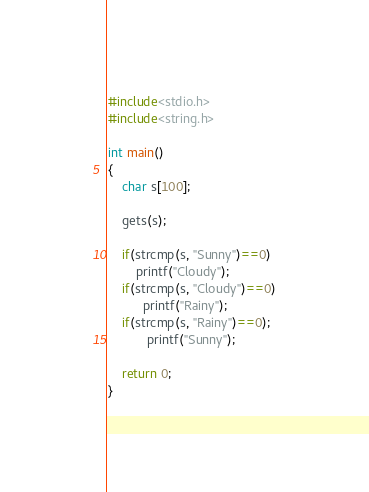Convert code to text. <code><loc_0><loc_0><loc_500><loc_500><_C_>#include<stdio.h>
#include<string.h>
 
int main()
{
    char s[100];
 
    gets(s);
 
    if(strcmp(s, "Sunny")==0)
        printf("Cloudy");
    if(strcmp(s, "Cloudy")==0)
          printf("Rainy");
    if(strcmp(s, "Rainy")==0);
           printf("Sunny");
 
    return 0;
}</code> 